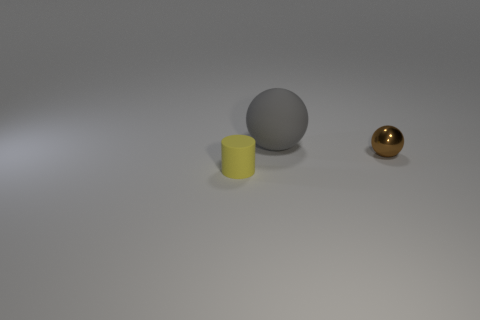Is there any other thing that has the same shape as the small yellow object?
Give a very brief answer. No. What material is the tiny object behind the object that is left of the big gray rubber sphere to the left of the small ball?
Your response must be concise. Metal. Is there a green metal object that has the same size as the gray sphere?
Offer a terse response. No. What is the color of the ball that is in front of the ball to the left of the tiny metallic sphere?
Ensure brevity in your answer.  Brown. How many big gray metallic cylinders are there?
Give a very brief answer. 0. Is the small rubber cylinder the same color as the small sphere?
Make the answer very short. No. Are there fewer rubber cylinders on the left side of the gray matte object than brown things that are to the left of the brown metallic object?
Give a very brief answer. No. The big matte sphere is what color?
Offer a very short reply. Gray. How many small objects have the same color as the large rubber thing?
Provide a succinct answer. 0. Are there any small cylinders on the right side of the small metallic thing?
Your answer should be very brief. No. 